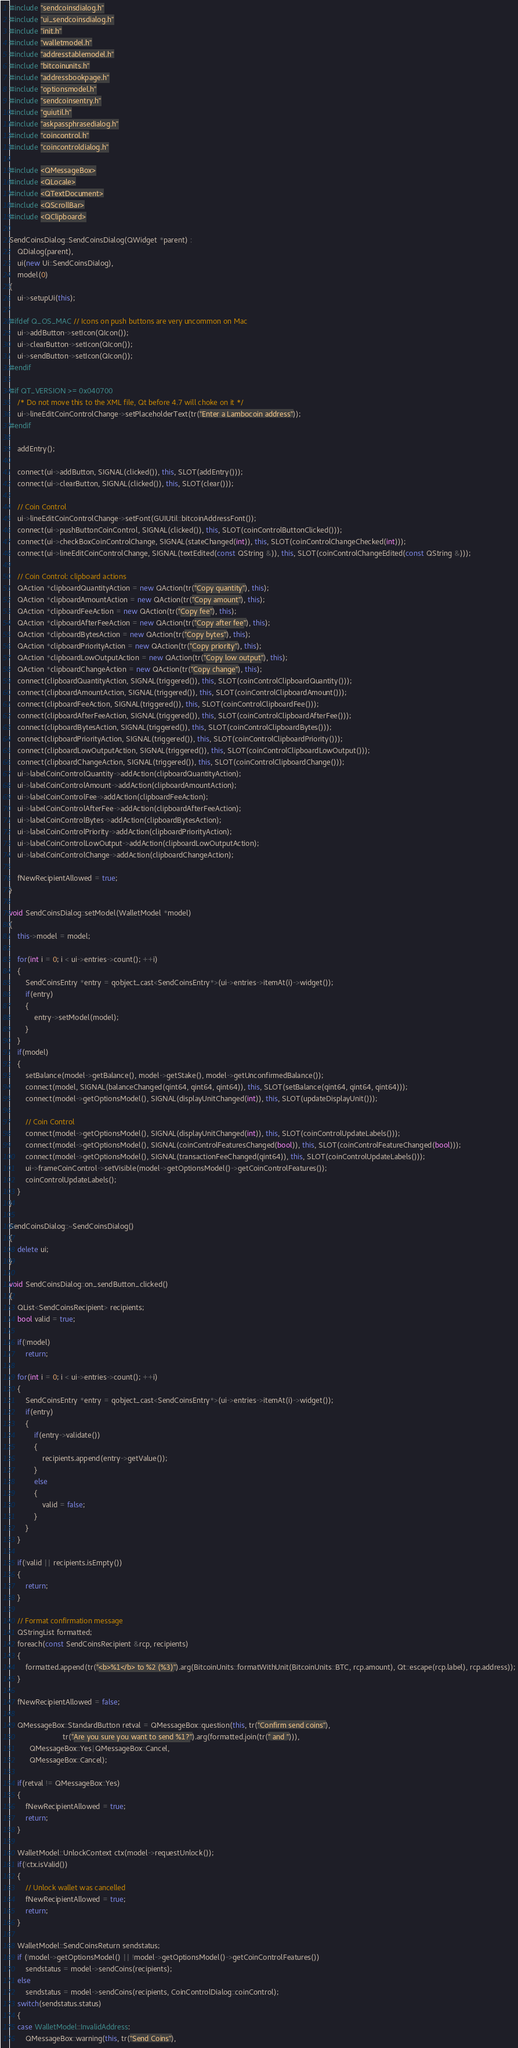<code> <loc_0><loc_0><loc_500><loc_500><_C++_>#include "sendcoinsdialog.h"
#include "ui_sendcoinsdialog.h"
#include "init.h"
#include "walletmodel.h"
#include "addresstablemodel.h"
#include "bitcoinunits.h"
#include "addressbookpage.h"
#include "optionsmodel.h"
#include "sendcoinsentry.h"
#include "guiutil.h"
#include "askpassphrasedialog.h"
#include "coincontrol.h"
#include "coincontroldialog.h"

#include <QMessageBox>
#include <QLocale>
#include <QTextDocument>
#include <QScrollBar>
#include <QClipboard>

SendCoinsDialog::SendCoinsDialog(QWidget *parent) :
    QDialog(parent),
    ui(new Ui::SendCoinsDialog),
    model(0)
{
    ui->setupUi(this);

#ifdef Q_OS_MAC // Icons on push buttons are very uncommon on Mac
    ui->addButton->setIcon(QIcon());
    ui->clearButton->setIcon(QIcon());
    ui->sendButton->setIcon(QIcon());
#endif

#if QT_VERSION >= 0x040700
    /* Do not move this to the XML file, Qt before 4.7 will choke on it */
    ui->lineEditCoinControlChange->setPlaceholderText(tr("Enter a Lambocoin address"));
#endif

    addEntry();

    connect(ui->addButton, SIGNAL(clicked()), this, SLOT(addEntry()));
    connect(ui->clearButton, SIGNAL(clicked()), this, SLOT(clear()));

    // Coin Control
    ui->lineEditCoinControlChange->setFont(GUIUtil::bitcoinAddressFont());
    connect(ui->pushButtonCoinControl, SIGNAL(clicked()), this, SLOT(coinControlButtonClicked()));
    connect(ui->checkBoxCoinControlChange, SIGNAL(stateChanged(int)), this, SLOT(coinControlChangeChecked(int)));
    connect(ui->lineEditCoinControlChange, SIGNAL(textEdited(const QString &)), this, SLOT(coinControlChangeEdited(const QString &)));

    // Coin Control: clipboard actions
    QAction *clipboardQuantityAction = new QAction(tr("Copy quantity"), this);
    QAction *clipboardAmountAction = new QAction(tr("Copy amount"), this);
    QAction *clipboardFeeAction = new QAction(tr("Copy fee"), this);
    QAction *clipboardAfterFeeAction = new QAction(tr("Copy after fee"), this);
    QAction *clipboardBytesAction = new QAction(tr("Copy bytes"), this);
    QAction *clipboardPriorityAction = new QAction(tr("Copy priority"), this);
    QAction *clipboardLowOutputAction = new QAction(tr("Copy low output"), this);
    QAction *clipboardChangeAction = new QAction(tr("Copy change"), this);
    connect(clipboardQuantityAction, SIGNAL(triggered()), this, SLOT(coinControlClipboardQuantity()));
    connect(clipboardAmountAction, SIGNAL(triggered()), this, SLOT(coinControlClipboardAmount()));
    connect(clipboardFeeAction, SIGNAL(triggered()), this, SLOT(coinControlClipboardFee()));
    connect(clipboardAfterFeeAction, SIGNAL(triggered()), this, SLOT(coinControlClipboardAfterFee()));
    connect(clipboardBytesAction, SIGNAL(triggered()), this, SLOT(coinControlClipboardBytes()));
    connect(clipboardPriorityAction, SIGNAL(triggered()), this, SLOT(coinControlClipboardPriority()));
    connect(clipboardLowOutputAction, SIGNAL(triggered()), this, SLOT(coinControlClipboardLowOutput()));
    connect(clipboardChangeAction, SIGNAL(triggered()), this, SLOT(coinControlClipboardChange()));
    ui->labelCoinControlQuantity->addAction(clipboardQuantityAction);
    ui->labelCoinControlAmount->addAction(clipboardAmountAction);
    ui->labelCoinControlFee->addAction(clipboardFeeAction);
    ui->labelCoinControlAfterFee->addAction(clipboardAfterFeeAction);
    ui->labelCoinControlBytes->addAction(clipboardBytesAction);
    ui->labelCoinControlPriority->addAction(clipboardPriorityAction);
    ui->labelCoinControlLowOutput->addAction(clipboardLowOutputAction);
    ui->labelCoinControlChange->addAction(clipboardChangeAction);

    fNewRecipientAllowed = true;
}

void SendCoinsDialog::setModel(WalletModel *model)
{
    this->model = model;

    for(int i = 0; i < ui->entries->count(); ++i)
    {
        SendCoinsEntry *entry = qobject_cast<SendCoinsEntry*>(ui->entries->itemAt(i)->widget());
        if(entry)
        {
            entry->setModel(model);
        }
    }
    if(model)
    {
        setBalance(model->getBalance(), model->getStake(), model->getUnconfirmedBalance());
        connect(model, SIGNAL(balanceChanged(qint64, qint64, qint64)), this, SLOT(setBalance(qint64, qint64, qint64)));
        connect(model->getOptionsModel(), SIGNAL(displayUnitChanged(int)), this, SLOT(updateDisplayUnit()));

        // Coin Control
        connect(model->getOptionsModel(), SIGNAL(displayUnitChanged(int)), this, SLOT(coinControlUpdateLabels()));
        connect(model->getOptionsModel(), SIGNAL(coinControlFeaturesChanged(bool)), this, SLOT(coinControlFeatureChanged(bool)));
        connect(model->getOptionsModel(), SIGNAL(transactionFeeChanged(qint64)), this, SLOT(coinControlUpdateLabels()));
        ui->frameCoinControl->setVisible(model->getOptionsModel()->getCoinControlFeatures());
        coinControlUpdateLabels();
    }
}

SendCoinsDialog::~SendCoinsDialog()
{
    delete ui;
}

void SendCoinsDialog::on_sendButton_clicked()
{
    QList<SendCoinsRecipient> recipients;
    bool valid = true;

    if(!model)
        return;

    for(int i = 0; i < ui->entries->count(); ++i)
    {
        SendCoinsEntry *entry = qobject_cast<SendCoinsEntry*>(ui->entries->itemAt(i)->widget());
        if(entry)
        {
            if(entry->validate())
            {
                recipients.append(entry->getValue());
            }
            else
            {
                valid = false;
            }
        }
    }

    if(!valid || recipients.isEmpty())
    {
        return;
    }

    // Format confirmation message
    QStringList formatted;
    foreach(const SendCoinsRecipient &rcp, recipients)
    {
        formatted.append(tr("<b>%1</b> to %2 (%3)").arg(BitcoinUnits::formatWithUnit(BitcoinUnits::BTC, rcp.amount), Qt::escape(rcp.label), rcp.address));
    }

    fNewRecipientAllowed = false;

    QMessageBox::StandardButton retval = QMessageBox::question(this, tr("Confirm send coins"),
                          tr("Are you sure you want to send %1?").arg(formatted.join(tr(" and "))),
          QMessageBox::Yes|QMessageBox::Cancel,
          QMessageBox::Cancel);

    if(retval != QMessageBox::Yes)
    {
        fNewRecipientAllowed = true;
        return;
    }

    WalletModel::UnlockContext ctx(model->requestUnlock());
    if(!ctx.isValid())
    {
        // Unlock wallet was cancelled
        fNewRecipientAllowed = true;
        return;
    }

    WalletModel::SendCoinsReturn sendstatus;
    if (!model->getOptionsModel() || !model->getOptionsModel()->getCoinControlFeatures())
        sendstatus = model->sendCoins(recipients);
    else
        sendstatus = model->sendCoins(recipients, CoinControlDialog::coinControl);
    switch(sendstatus.status)
    {
    case WalletModel::InvalidAddress:
        QMessageBox::warning(this, tr("Send Coins"),</code> 